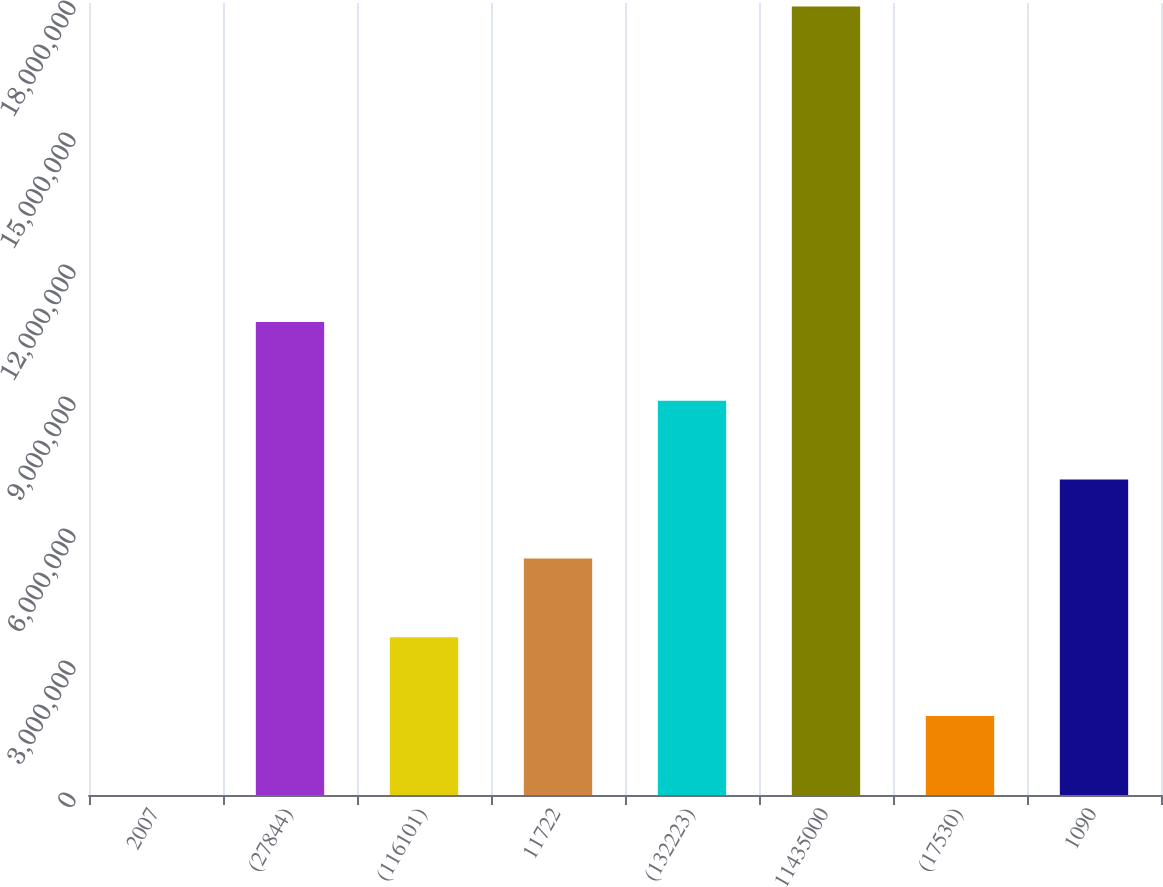Convert chart to OTSL. <chart><loc_0><loc_0><loc_500><loc_500><bar_chart><fcel>2007<fcel>(27844)<fcel>(116101)<fcel>11722<fcel>(132223)<fcel>11435000<fcel>(17530)<fcel>1090<nl><fcel>2005<fcel>1.07528e+07<fcel>3.5856e+06<fcel>5.3774e+06<fcel>8.961e+06<fcel>1.792e+07<fcel>1.7938e+06<fcel>7.1692e+06<nl></chart> 